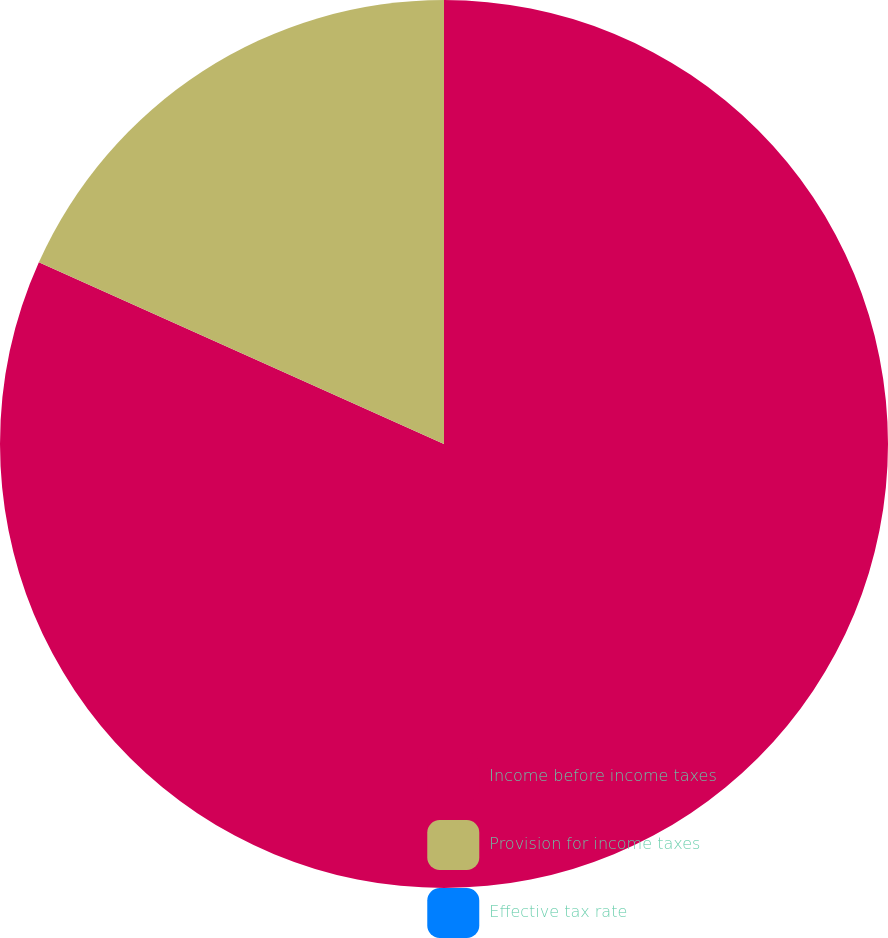Convert chart. <chart><loc_0><loc_0><loc_500><loc_500><pie_chart><fcel>Income before income taxes<fcel>Provision for income taxes<fcel>Effective tax rate<nl><fcel>81.71%<fcel>18.29%<fcel>0.0%<nl></chart> 